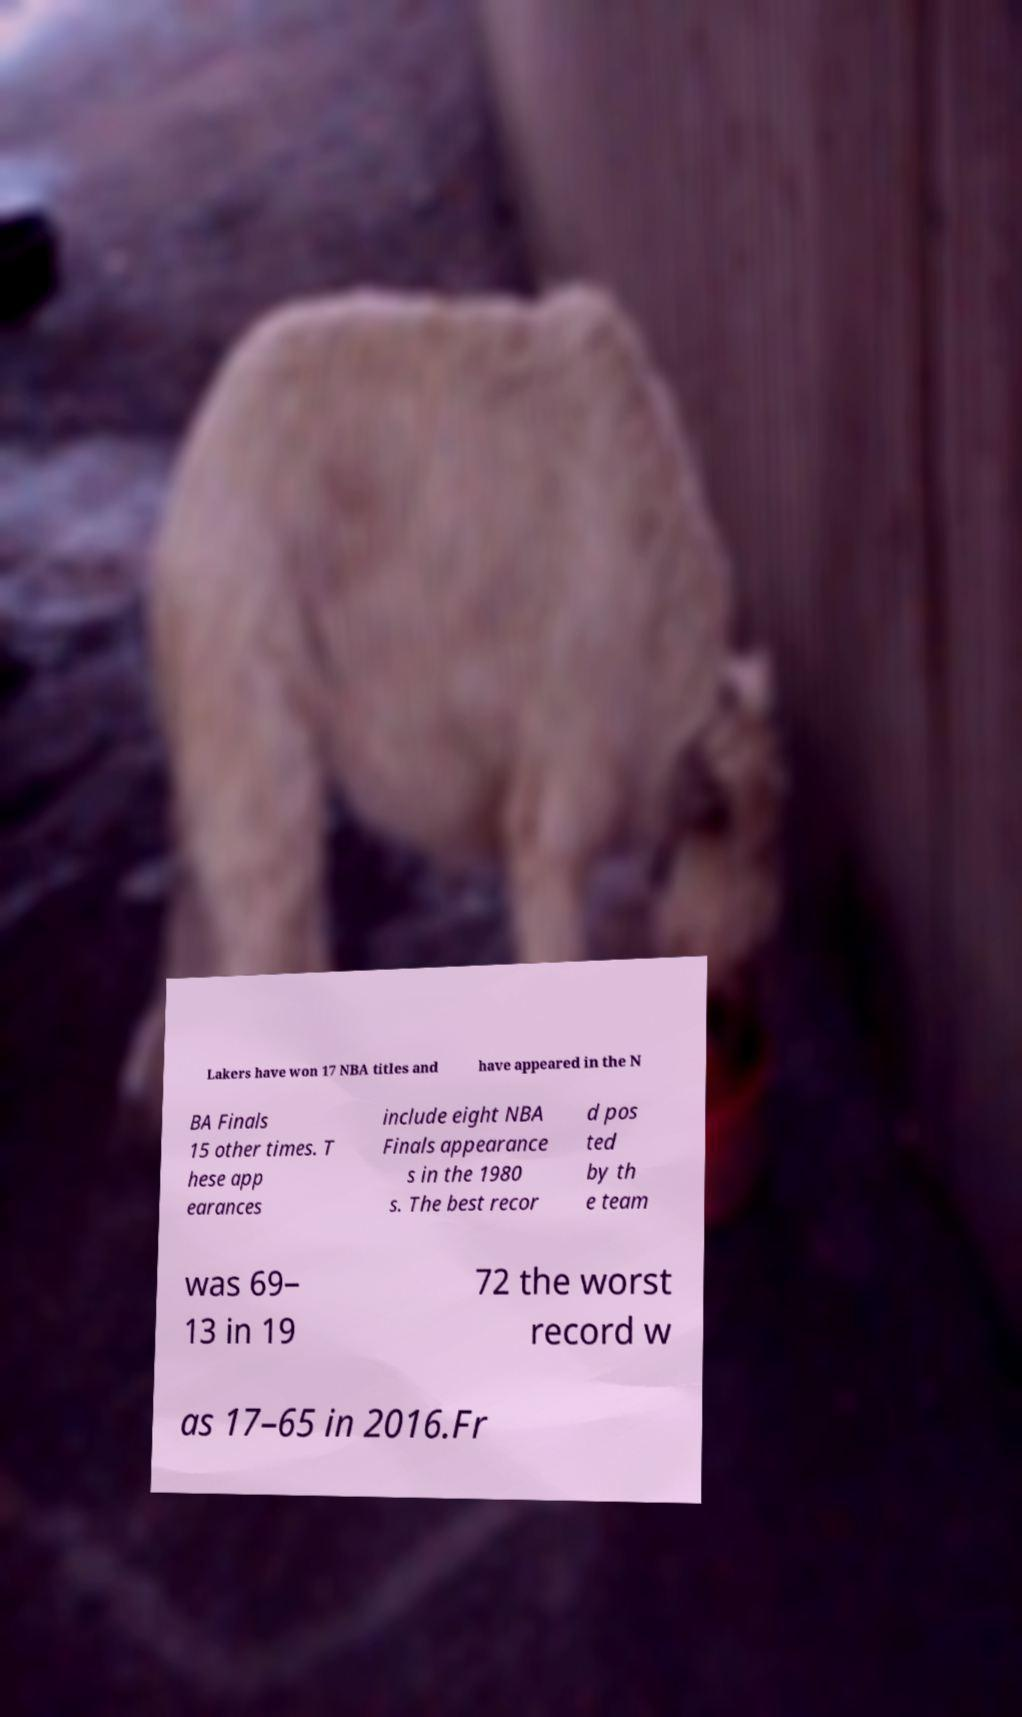Could you assist in decoding the text presented in this image and type it out clearly? Lakers have won 17 NBA titles and have appeared in the N BA Finals 15 other times. T hese app earances include eight NBA Finals appearance s in the 1980 s. The best recor d pos ted by th e team was 69– 13 in 19 72 the worst record w as 17–65 in 2016.Fr 